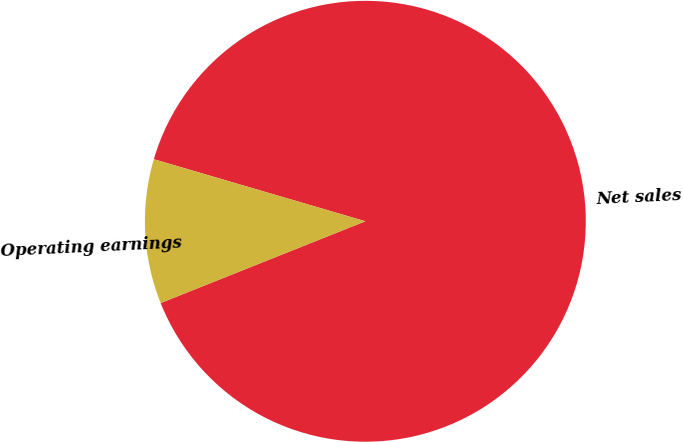<chart> <loc_0><loc_0><loc_500><loc_500><pie_chart><fcel>Net sales<fcel>Operating earnings<nl><fcel>89.41%<fcel>10.59%<nl></chart> 